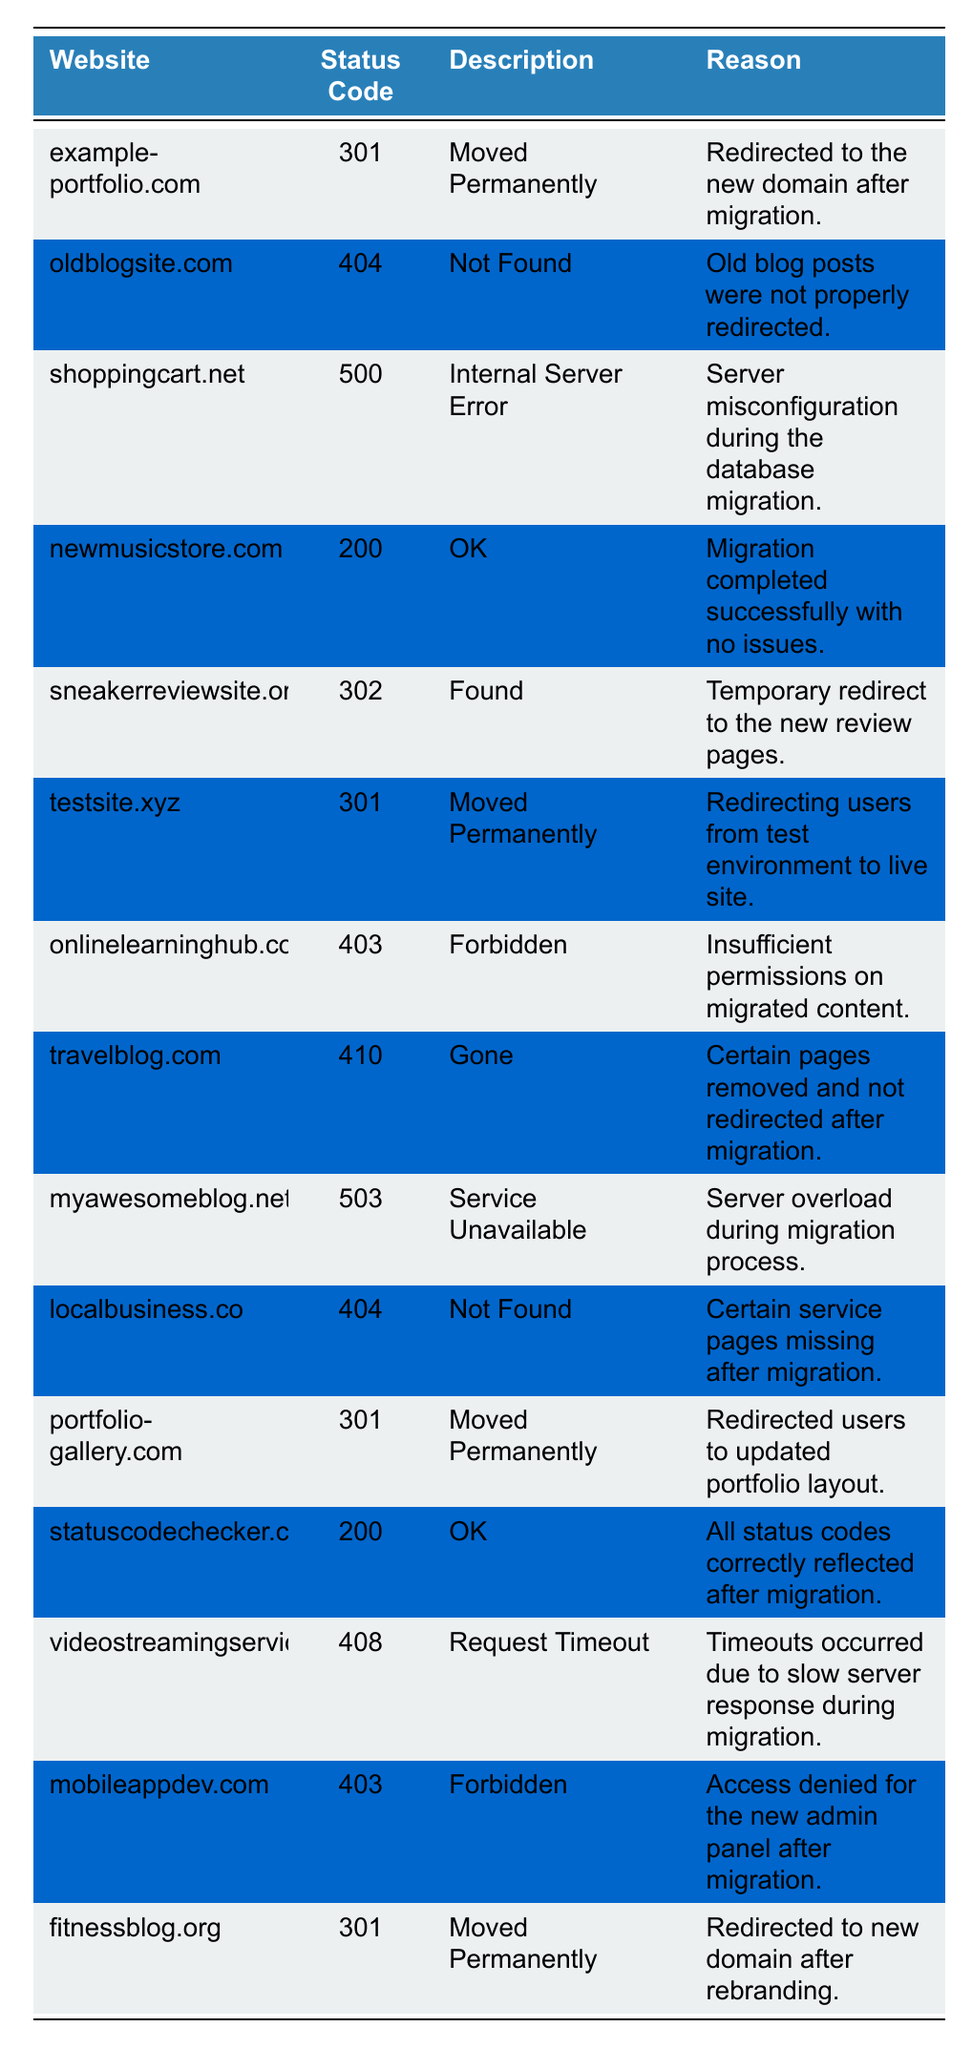What is the status code for "example-portfolio.com"? The table lists the website "example-portfolio.com" in the first row, which has a status code of 301.
Answer: 301 Which website returned a status code of 500? The table shows that "shoppingcart.net" is associated with a status code of 500, which indicates an internal server error.
Answer: shoppingcart.net How many websites returned a status code of 301? Counting the rows with a status code of 301 in the table, we find four websites: "example-portfolio.com," "testsite.xyz," "portfolio-gallery.com," and "fitnessblog.org."
Answer: 4 Is there any website that returned a status code of 404? The table indicates that both "oldblogsite.com" and "localbusiness.co" have a status code of 404, confirming that they were not found.
Answer: Yes What was the reason for the status code 503? The status code 503 is associated with "myawesomeblog.net," and the reason provided is a server overload during the migration process.
Answer: Server overload during migration Which website had a successful migration with a status code of 200? "newmusicstore.com" is the website listed in the table with a status code of 200, signifying a successful migration without issues.
Answer: newmusicstore.com Are there any sites that received a status code of 403? Both "onlinelearninghub.com" and "mobileappdev.com" are listed with a status code of 403, indicating forbidden access.
Answer: Yes What is the total number of different status codes recorded in the data? The table shows 10 different status codes: 301, 404, 500, 200, 302, 403, 410, 503, 408, and an additional 200 for two websites, leading to a total of 10 unique codes.
Answer: 10 Which website was marked as "Gone"? "travelblog.com" is the website that has the status code 410, which is described as "Gone."
Answer: travelblog.com What is the difference in status codes between "sneakerreviewsite.org" and "myawesomeblog.net"? "sneakerreviewsite.org" returned a status code of 302, and "myawesomeblog.net" returned a status code of 503. The difference is 503 - 302 = 201.
Answer: 201 How many websites had a status code indicating a redirect? The websites with status codes indicating a redirect are "example-portfolio.com" (301), "sneakerreviewsite.org" (302), "testsite.xyz" (301), "portfolio-gallery.com" (301), and "fitnessblog.org" (301). Counting them gives us five.
Answer: 5 